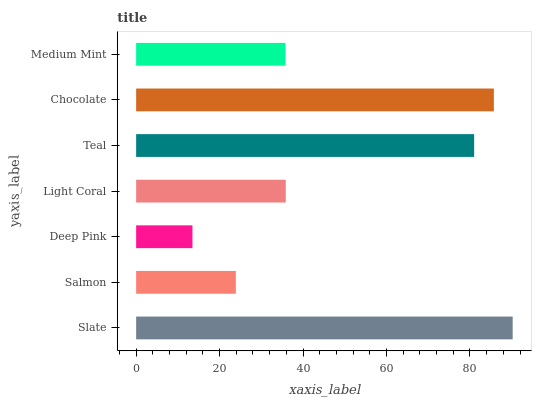Is Deep Pink the minimum?
Answer yes or no. Yes. Is Slate the maximum?
Answer yes or no. Yes. Is Salmon the minimum?
Answer yes or no. No. Is Salmon the maximum?
Answer yes or no. No. Is Slate greater than Salmon?
Answer yes or no. Yes. Is Salmon less than Slate?
Answer yes or no. Yes. Is Salmon greater than Slate?
Answer yes or no. No. Is Slate less than Salmon?
Answer yes or no. No. Is Light Coral the high median?
Answer yes or no. Yes. Is Light Coral the low median?
Answer yes or no. Yes. Is Medium Mint the high median?
Answer yes or no. No. Is Slate the low median?
Answer yes or no. No. 